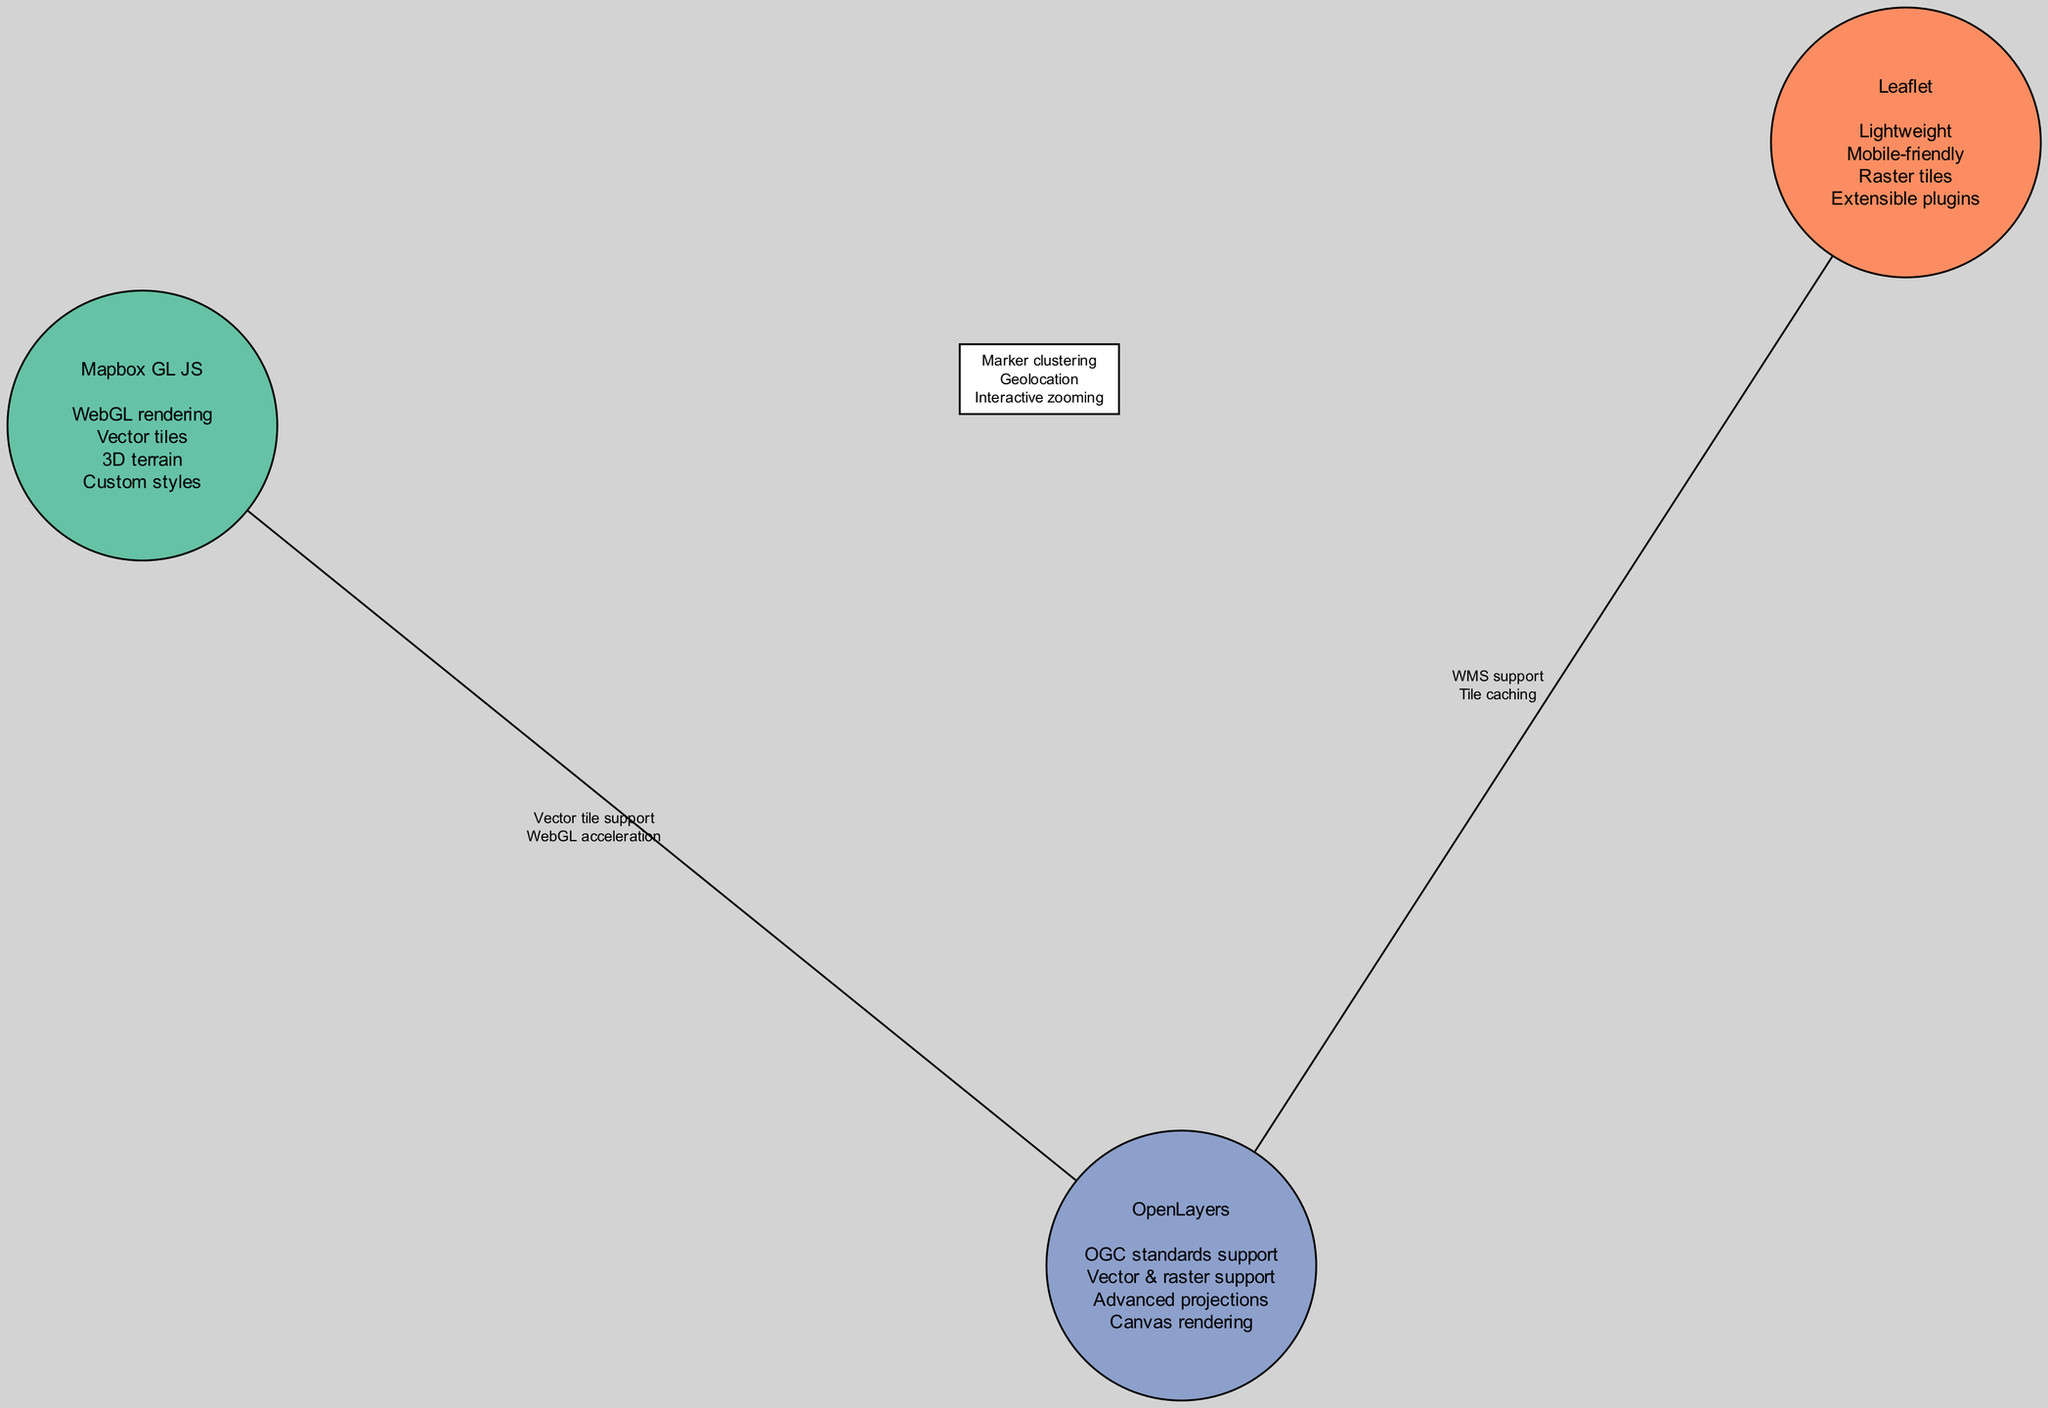What features are unique to Mapbox GL JS? The features unique to Mapbox GL JS can be found in the circle labeled "Mapbox GL JS". They include "WebGL rendering", "Vector tiles", "3D terrain", and "Custom styles". Since none of these features are listed in the intersections or in the features of the other libraries, they are specific to Mapbox GL JS.
Answer: WebGL rendering, Vector tiles, 3D terrain, Custom styles How many shared features are there between Leaflet and OpenLayers? The intersection containing Leaflet and OpenLayers displays two shared features: "WMS support" and "Tile caching". By counting these features in the intersection, we find the number of shared features between these two libraries.
Answer: 2 Which libraries share vector tile support? The shared feature "Vector tile support" is present in the intersection between Mapbox GL JS and OpenLayers. Therefore, the libraries that share this feature can be identified as those listed in that intersection.
Answer: Mapbox GL JS, OpenLayers What is a common feature among all three libraries? The shared features among all three libraries can be found in the intersection that connects Mapbox GL JS, Leaflet, and OpenLayers. The feature listed there is "Marker clustering", "Geolocation", and "Interactive zooming". These features represent what all three libraries have in common.
Answer: Marker clustering, Geolocation, Interactive zooming How many total libraries are represented in the diagram? The diagram contains three circles representing the libraries: Mapbox GL JS, Leaflet, and OpenLayers. By counting these, we determine the total number of libraries represented in the diagram.
Answer: 3 